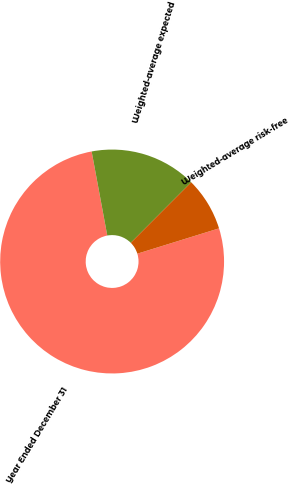<chart> <loc_0><loc_0><loc_500><loc_500><pie_chart><fcel>Year Ended December 31<fcel>Weighted-average expected<fcel>Weighted-average risk-free<nl><fcel>76.86%<fcel>15.41%<fcel>7.73%<nl></chart> 